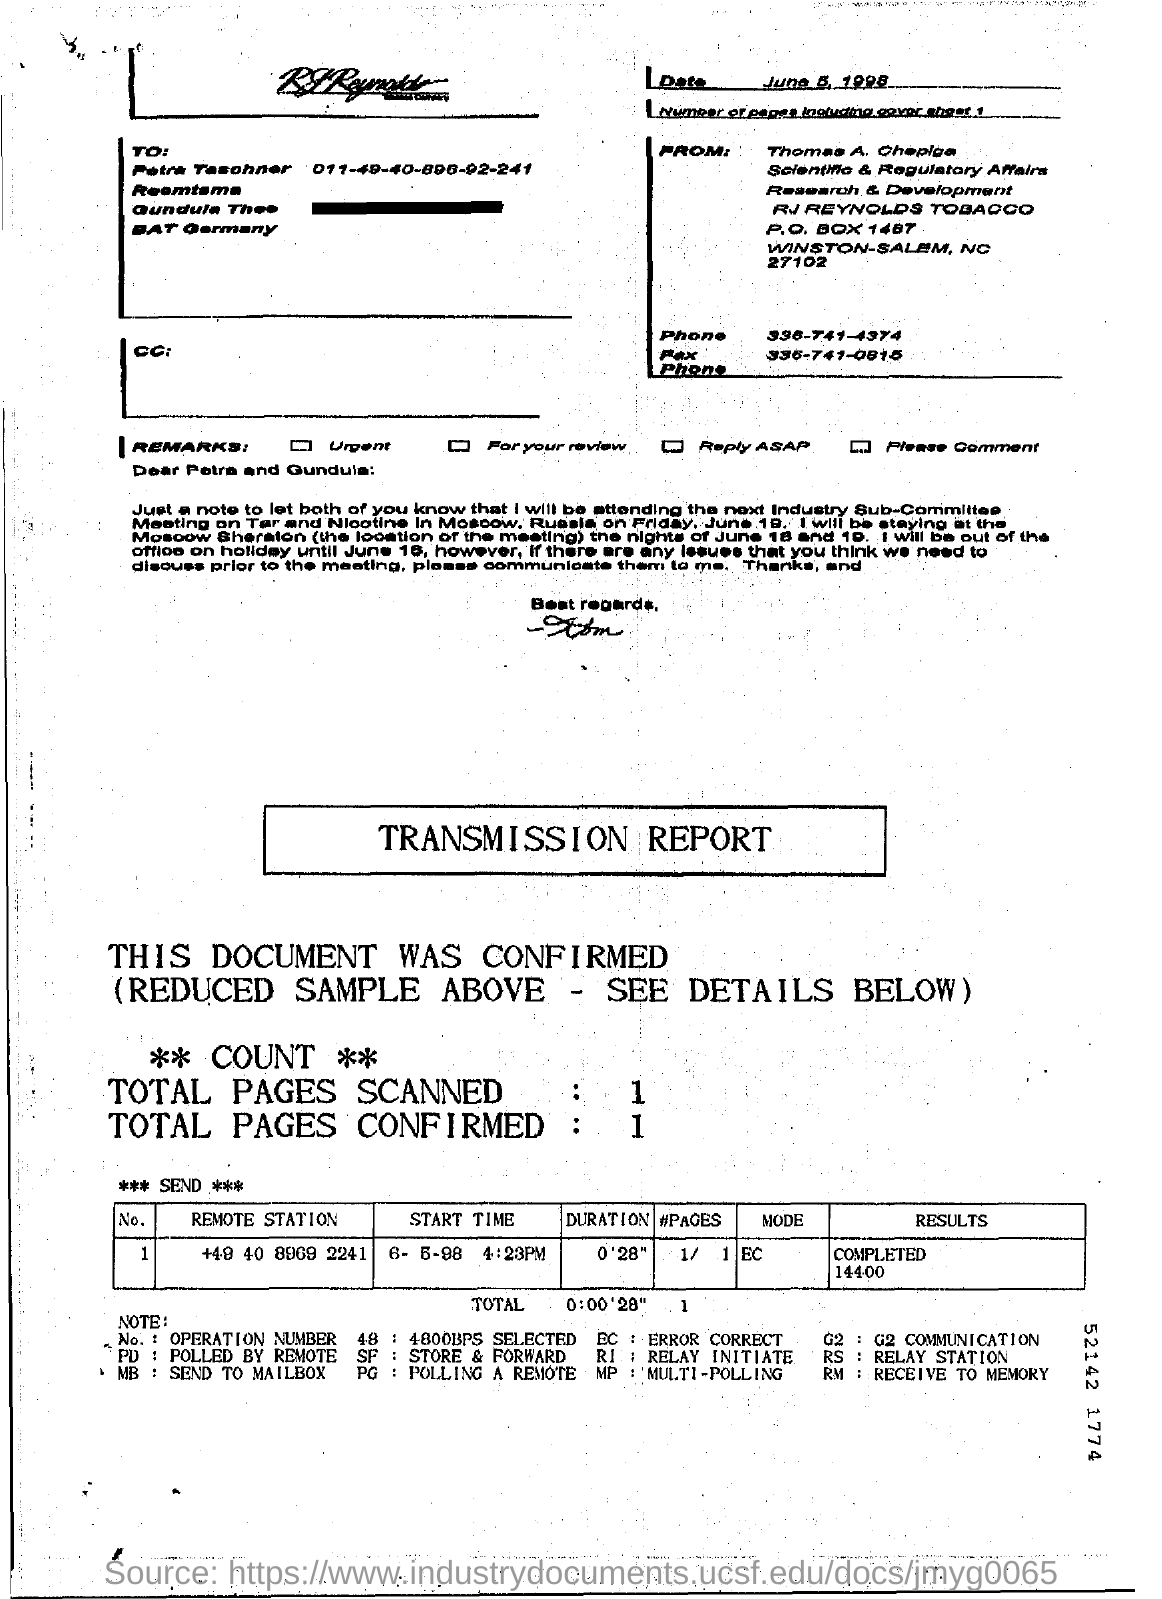Outline some significant characteristics in this image. The mode in the transmission report is "ERROR CORRECT..". There is one page in the fax including the cover sheet. The sender of the fax is Thomas A. Chepiga. The phone number of Thomas A. Chepiga is 336-741-0815. The date of the fax transmission is June 5th, 1998. 